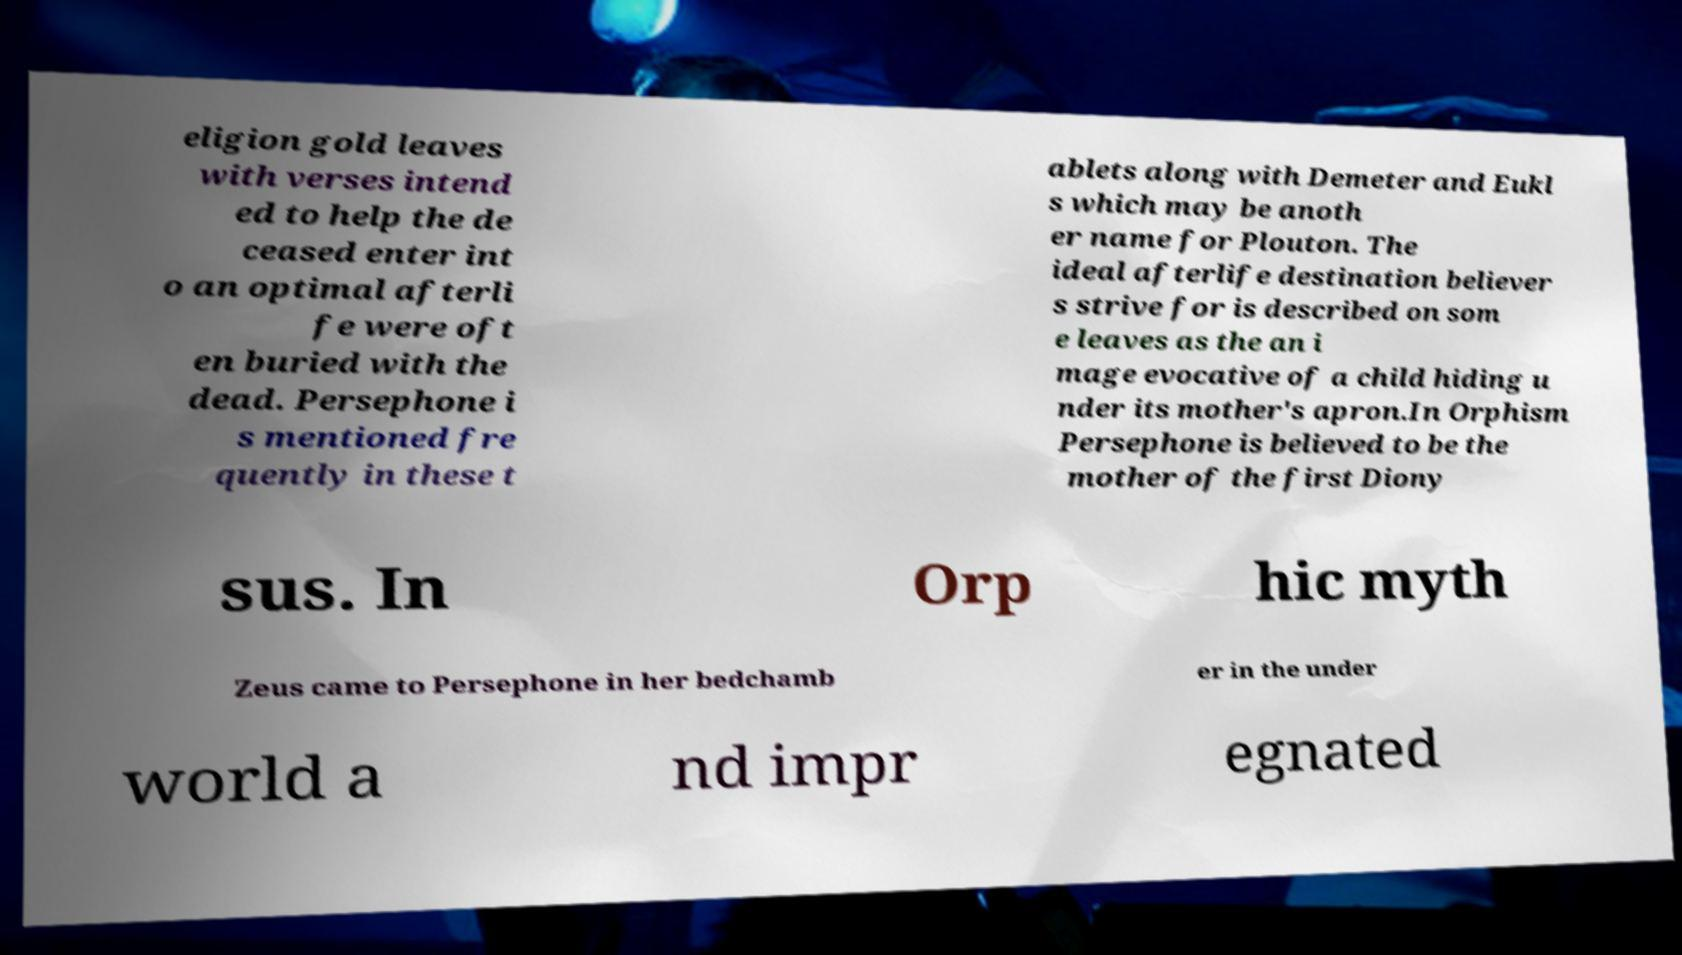Please read and relay the text visible in this image. What does it say? eligion gold leaves with verses intend ed to help the de ceased enter int o an optimal afterli fe were oft en buried with the dead. Persephone i s mentioned fre quently in these t ablets along with Demeter and Eukl s which may be anoth er name for Plouton. The ideal afterlife destination believer s strive for is described on som e leaves as the an i mage evocative of a child hiding u nder its mother's apron.In Orphism Persephone is believed to be the mother of the first Diony sus. In Orp hic myth Zeus came to Persephone in her bedchamb er in the under world a nd impr egnated 